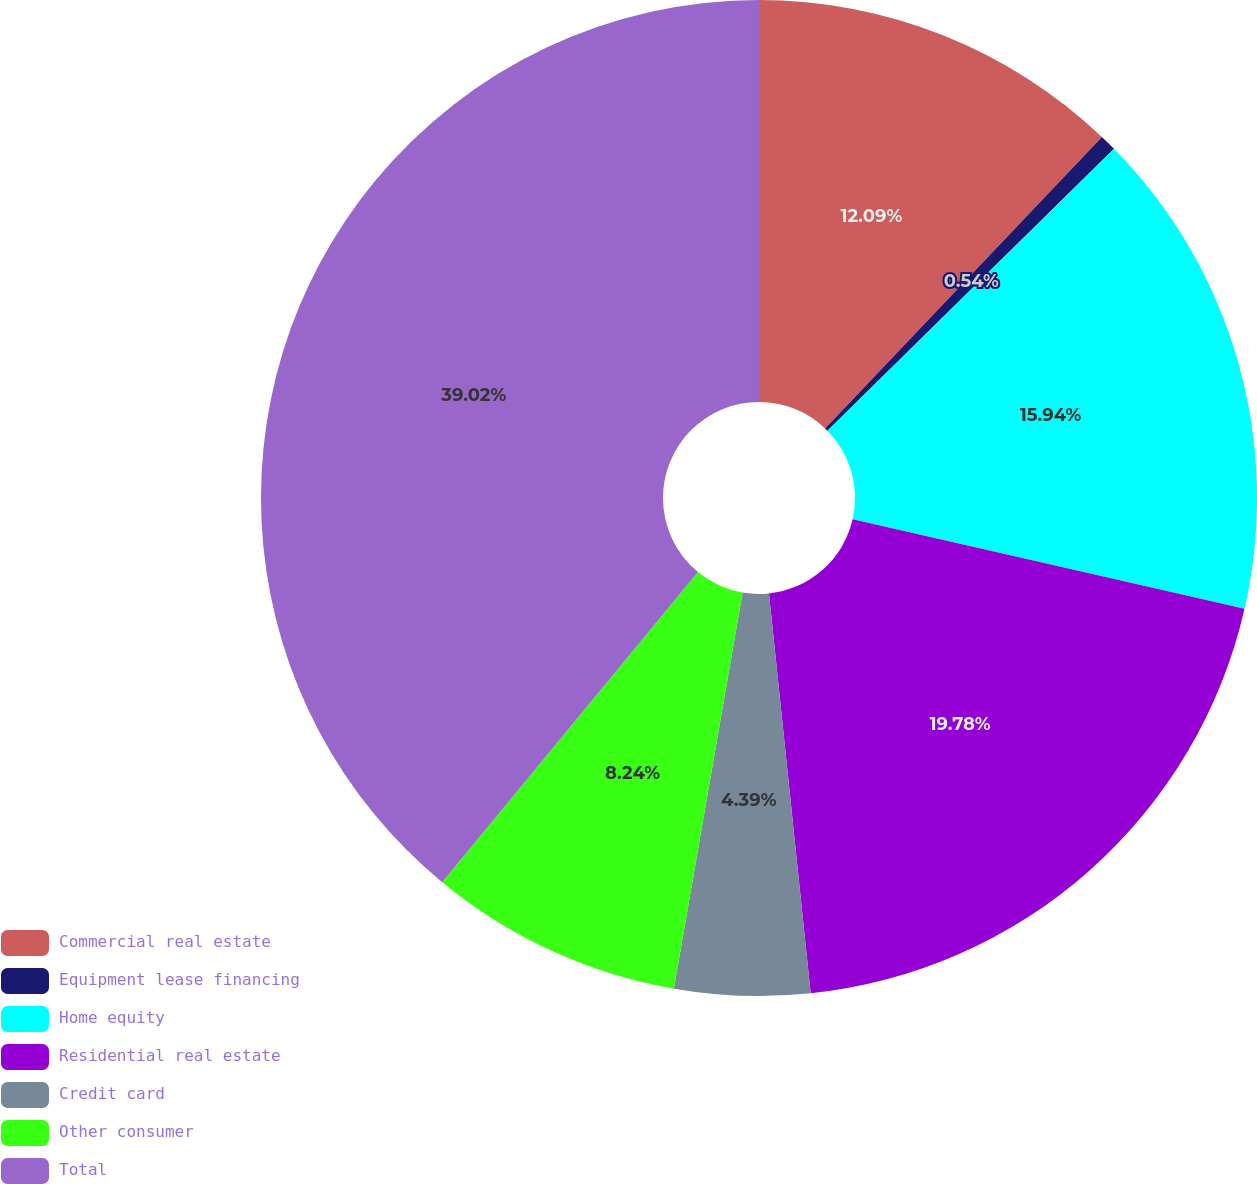<chart> <loc_0><loc_0><loc_500><loc_500><pie_chart><fcel>Commercial real estate<fcel>Equipment lease financing<fcel>Home equity<fcel>Residential real estate<fcel>Credit card<fcel>Other consumer<fcel>Total<nl><fcel>12.09%<fcel>0.54%<fcel>15.94%<fcel>19.78%<fcel>4.39%<fcel>8.24%<fcel>39.03%<nl></chart> 